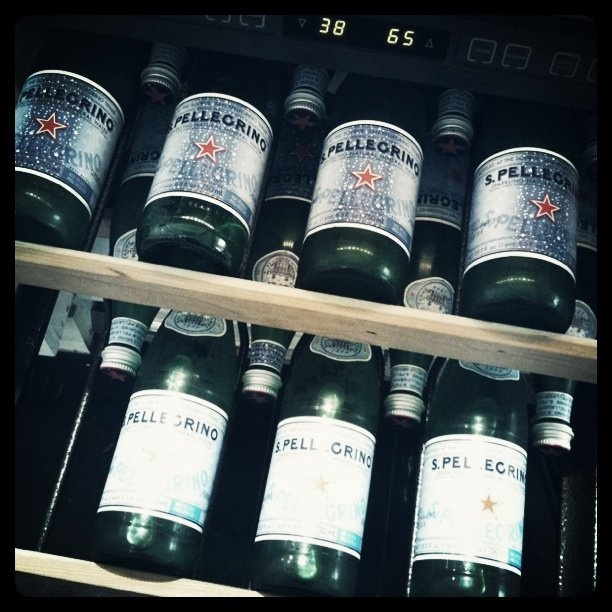Describe the objects in this image and their specific colors. I can see refrigerator in black, white, darkgray, gray, and purple tones, bottle in black, blue, gray, and darkblue tones, bottle in black, white, and teal tones, bottle in black, white, and teal tones, and bottle in black, white, and teal tones in this image. 